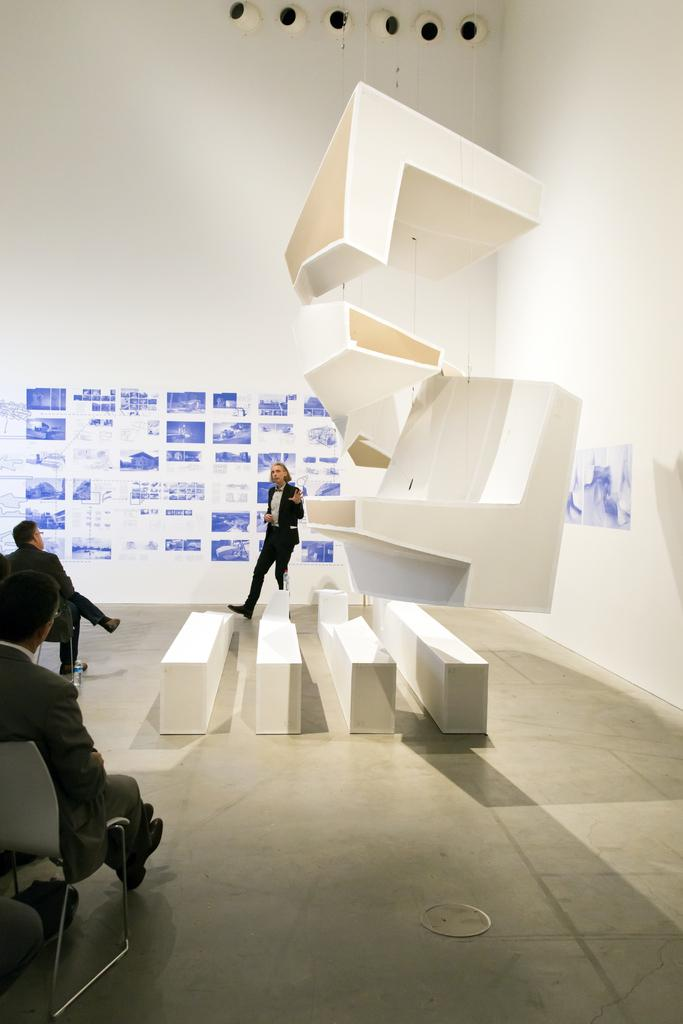What are the people in the image doing? The people in the image are sitting on chairs. What can be seen in the background of the image? There is architecture visible in the image. What is the person in the image doing while standing? One person is standing and talking in the image. How many bikes are parked near the tent in the image? There is no tent or bikes present in the image. What is the current weather like in the image? The provided facts do not mention the weather, so it cannot be determined from the image. 